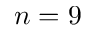<formula> <loc_0><loc_0><loc_500><loc_500>n = 9</formula> 